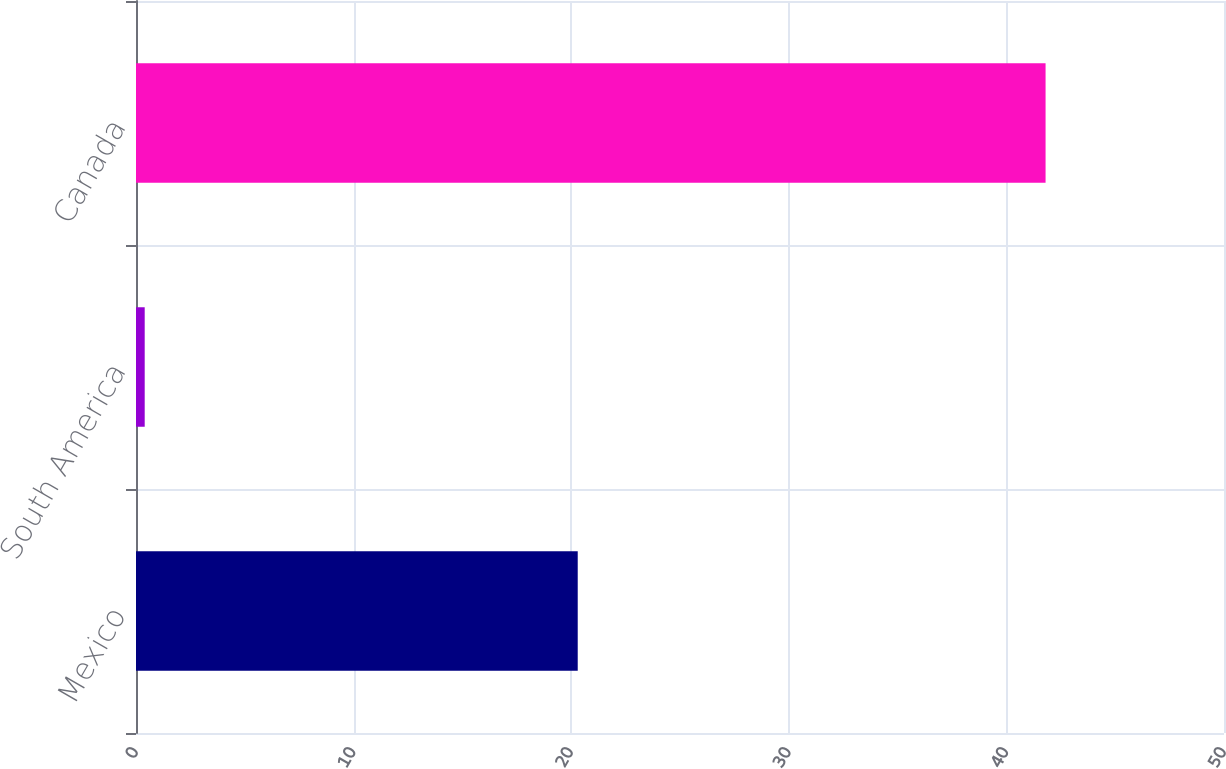Convert chart to OTSL. <chart><loc_0><loc_0><loc_500><loc_500><bar_chart><fcel>Mexico<fcel>South America<fcel>Canada<nl><fcel>20.3<fcel>0.4<fcel>41.8<nl></chart> 